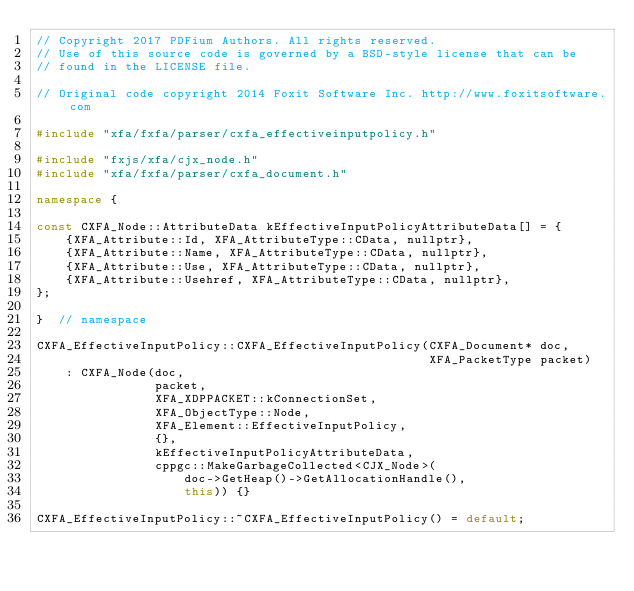<code> <loc_0><loc_0><loc_500><loc_500><_C++_>// Copyright 2017 PDFium Authors. All rights reserved.
// Use of this source code is governed by a BSD-style license that can be
// found in the LICENSE file.

// Original code copyright 2014 Foxit Software Inc. http://www.foxitsoftware.com

#include "xfa/fxfa/parser/cxfa_effectiveinputpolicy.h"

#include "fxjs/xfa/cjx_node.h"
#include "xfa/fxfa/parser/cxfa_document.h"

namespace {

const CXFA_Node::AttributeData kEffectiveInputPolicyAttributeData[] = {
    {XFA_Attribute::Id, XFA_AttributeType::CData, nullptr},
    {XFA_Attribute::Name, XFA_AttributeType::CData, nullptr},
    {XFA_Attribute::Use, XFA_AttributeType::CData, nullptr},
    {XFA_Attribute::Usehref, XFA_AttributeType::CData, nullptr},
};

}  // namespace

CXFA_EffectiveInputPolicy::CXFA_EffectiveInputPolicy(CXFA_Document* doc,
                                                     XFA_PacketType packet)
    : CXFA_Node(doc,
                packet,
                XFA_XDPPACKET::kConnectionSet,
                XFA_ObjectType::Node,
                XFA_Element::EffectiveInputPolicy,
                {},
                kEffectiveInputPolicyAttributeData,
                cppgc::MakeGarbageCollected<CJX_Node>(
                    doc->GetHeap()->GetAllocationHandle(),
                    this)) {}

CXFA_EffectiveInputPolicy::~CXFA_EffectiveInputPolicy() = default;
</code> 